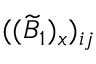Convert formula to latex. <formula><loc_0><loc_0><loc_500><loc_500>( ( \widetilde { B } _ { 1 } ) _ { x } ) _ { i j }</formula> 